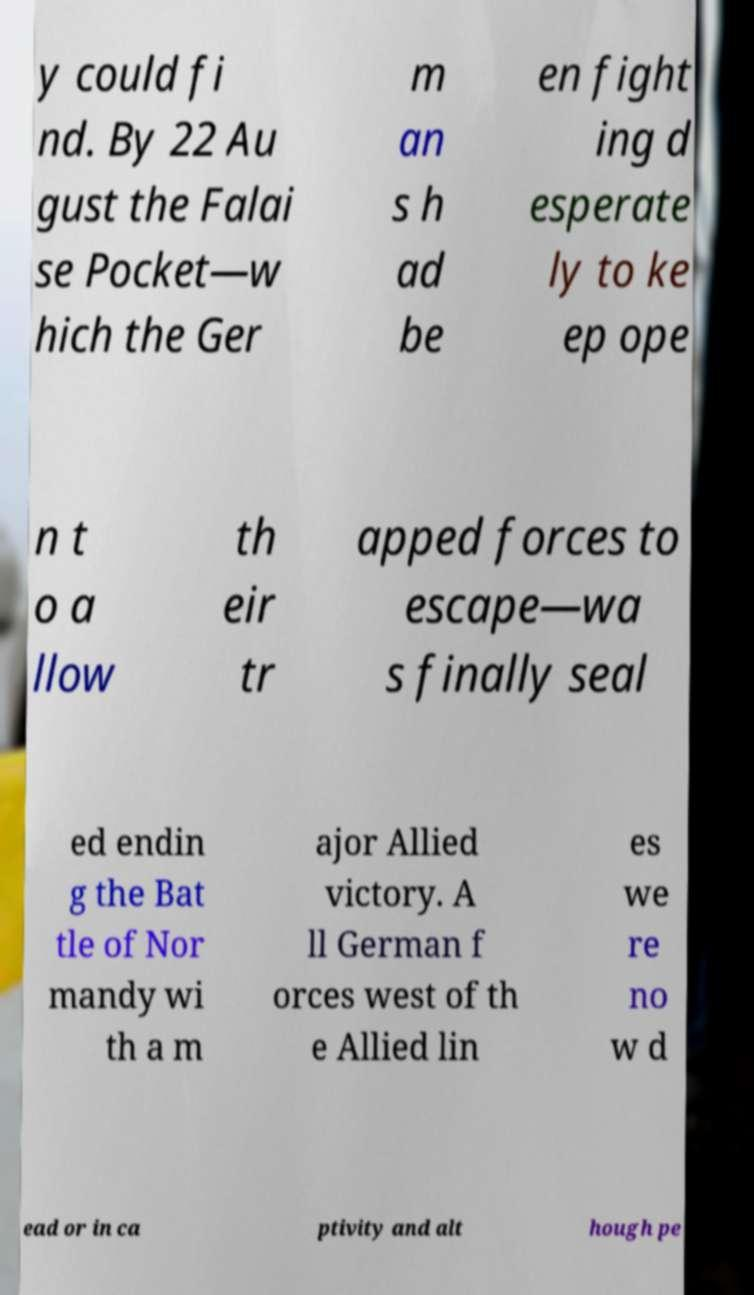Please read and relay the text visible in this image. What does it say? y could fi nd. By 22 Au gust the Falai se Pocket—w hich the Ger m an s h ad be en fight ing d esperate ly to ke ep ope n t o a llow th eir tr apped forces to escape—wa s finally seal ed endin g the Bat tle of Nor mandy wi th a m ajor Allied victory. A ll German f orces west of th e Allied lin es we re no w d ead or in ca ptivity and alt hough pe 